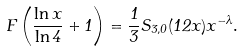Convert formula to latex. <formula><loc_0><loc_0><loc_500><loc_500>F \left ( \frac { \ln x } { \ln 4 } + 1 \right ) = \frac { 1 } { 3 } S _ { 3 , 0 } ( 1 2 x ) x ^ { - \lambda } .</formula> 